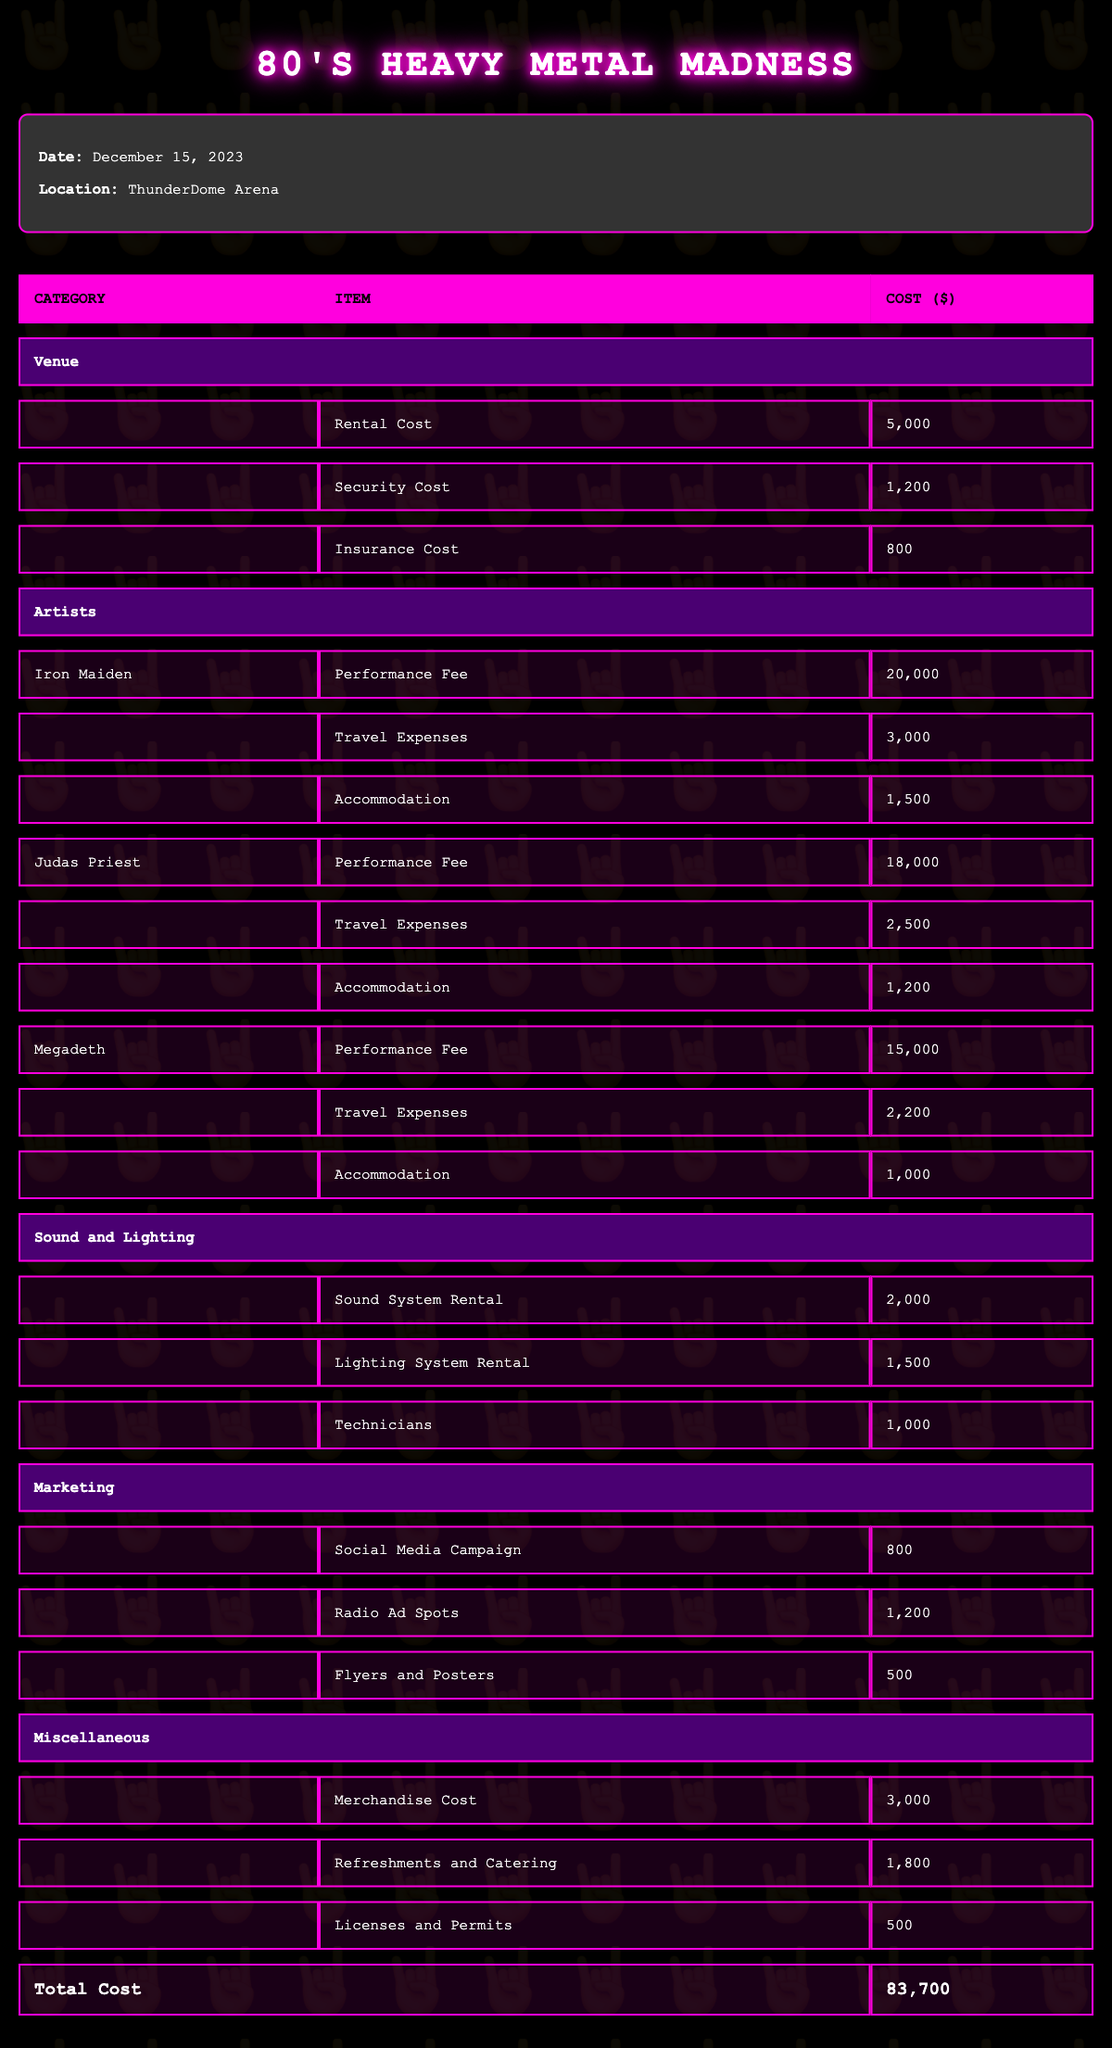What is the total cost for hosting the event? The total cost is listed in the last row of the table under the "Total Cost" column. The value provided there is 83,700.
Answer: 83,700 What are the individual performance fees for the artists? The performance fees for the artists listed are as follows: Iron Maiden - 20,000, Judas Priest - 18,000, and Megadeth - 15,000.
Answer: Iron Maiden: 20,000, Judas Priest: 18,000, Megadeth: 15,000 How much is spent on marketing? The marketing costs consist of three items: Social Media Campaign (800), Radio Ad Spots (1,200), and Flyers and Posters (500). Summing these gives 800 + 1,200 + 500 = 2,500.
Answer: 2,500 Is the merchandise cost more than the combined total of security and insurance costs? The merchandise cost is 3,000, while the combined costs of security (1,200) and insurance (800) total 2,000. Since 3,000 > 2,000, the answer is yes.
Answer: Yes What percentage of the total cost is attributed to artist performance fees? First, we need to sum the performance fees: 20,000 + 18,000 + 15,000 = 53,000. Then, to find the percentage of total cost, we use (53,000 / 83,700) * 100, which equals approximately 63.36%.
Answer: 63.36% 